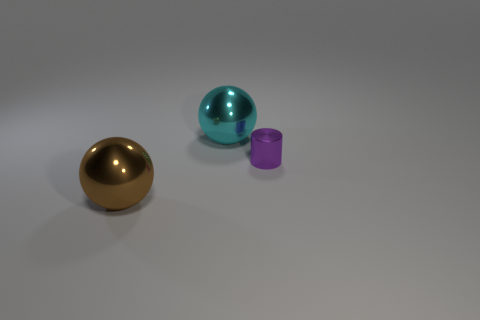Add 1 shiny objects. How many objects exist? 4 Subtract all balls. How many objects are left? 1 Add 1 tiny metal things. How many tiny metal things exist? 2 Subtract 0 cyan cubes. How many objects are left? 3 Subtract all purple cylinders. Subtract all small cylinders. How many objects are left? 1 Add 1 shiny objects. How many shiny objects are left? 4 